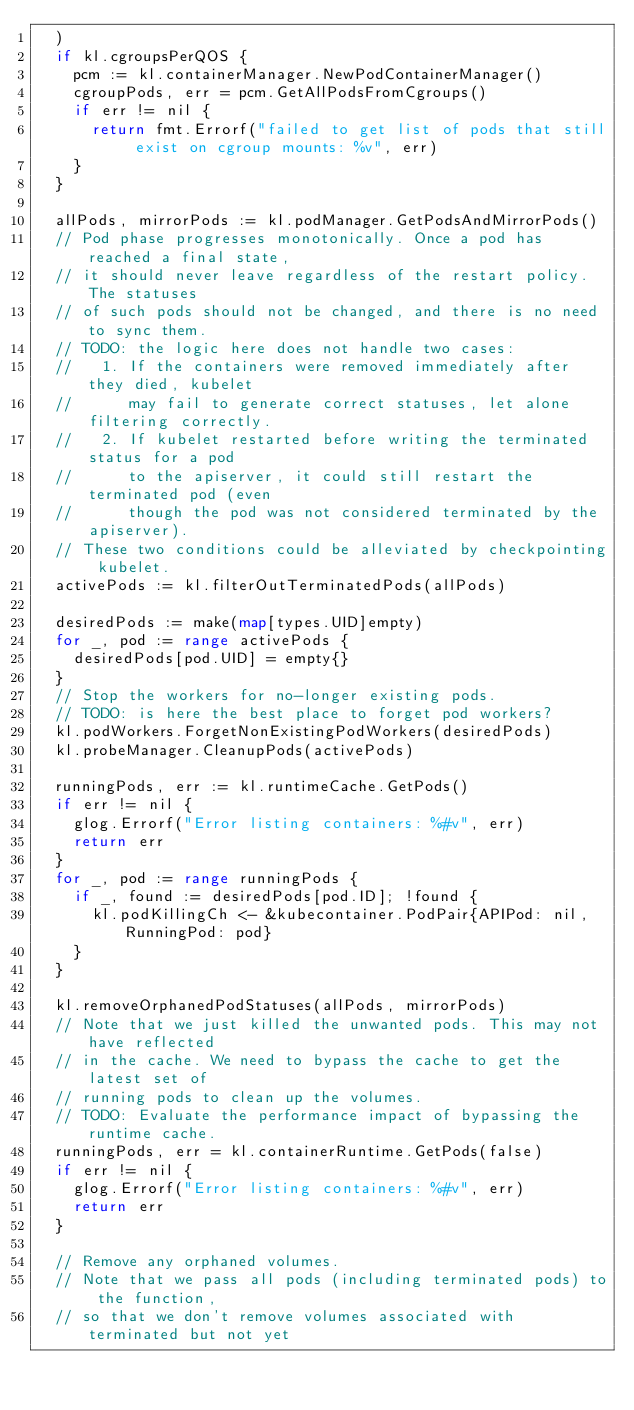Convert code to text. <code><loc_0><loc_0><loc_500><loc_500><_Go_>	)
	if kl.cgroupsPerQOS {
		pcm := kl.containerManager.NewPodContainerManager()
		cgroupPods, err = pcm.GetAllPodsFromCgroups()
		if err != nil {
			return fmt.Errorf("failed to get list of pods that still exist on cgroup mounts: %v", err)
		}
	}

	allPods, mirrorPods := kl.podManager.GetPodsAndMirrorPods()
	// Pod phase progresses monotonically. Once a pod has reached a final state,
	// it should never leave regardless of the restart policy. The statuses
	// of such pods should not be changed, and there is no need to sync them.
	// TODO: the logic here does not handle two cases:
	//   1. If the containers were removed immediately after they died, kubelet
	//      may fail to generate correct statuses, let alone filtering correctly.
	//   2. If kubelet restarted before writing the terminated status for a pod
	//      to the apiserver, it could still restart the terminated pod (even
	//      though the pod was not considered terminated by the apiserver).
	// These two conditions could be alleviated by checkpointing kubelet.
	activePods := kl.filterOutTerminatedPods(allPods)

	desiredPods := make(map[types.UID]empty)
	for _, pod := range activePods {
		desiredPods[pod.UID] = empty{}
	}
	// Stop the workers for no-longer existing pods.
	// TODO: is here the best place to forget pod workers?
	kl.podWorkers.ForgetNonExistingPodWorkers(desiredPods)
	kl.probeManager.CleanupPods(activePods)

	runningPods, err := kl.runtimeCache.GetPods()
	if err != nil {
		glog.Errorf("Error listing containers: %#v", err)
		return err
	}
	for _, pod := range runningPods {
		if _, found := desiredPods[pod.ID]; !found {
			kl.podKillingCh <- &kubecontainer.PodPair{APIPod: nil, RunningPod: pod}
		}
	}

	kl.removeOrphanedPodStatuses(allPods, mirrorPods)
	// Note that we just killed the unwanted pods. This may not have reflected
	// in the cache. We need to bypass the cache to get the latest set of
	// running pods to clean up the volumes.
	// TODO: Evaluate the performance impact of bypassing the runtime cache.
	runningPods, err = kl.containerRuntime.GetPods(false)
	if err != nil {
		glog.Errorf("Error listing containers: %#v", err)
		return err
	}

	// Remove any orphaned volumes.
	// Note that we pass all pods (including terminated pods) to the function,
	// so that we don't remove volumes associated with terminated but not yet</code> 